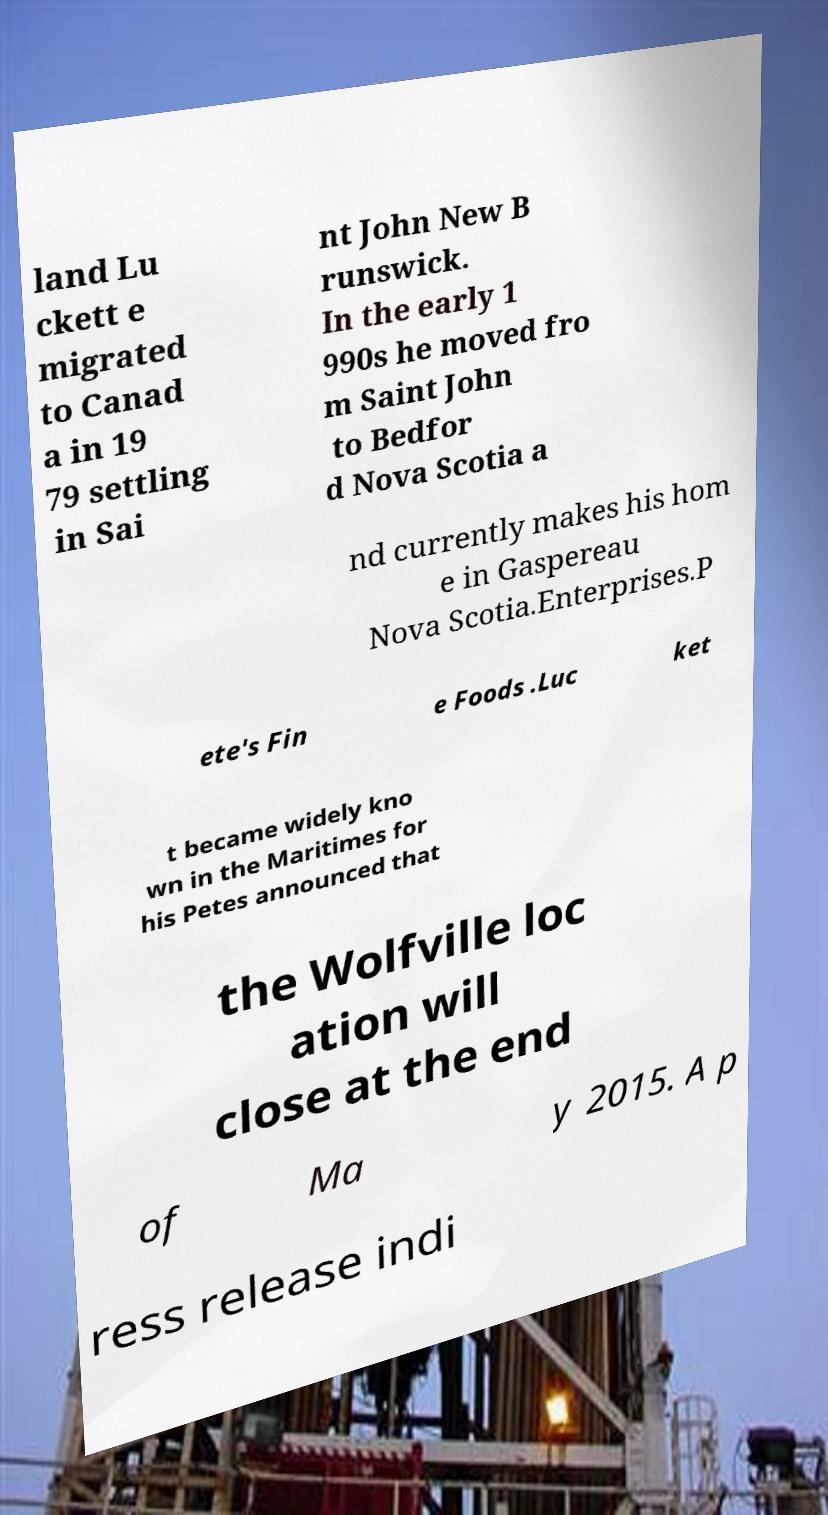What messages or text are displayed in this image? I need them in a readable, typed format. land Lu ckett e migrated to Canad a in 19 79 settling in Sai nt John New B runswick. In the early 1 990s he moved fro m Saint John to Bedfor d Nova Scotia a nd currently makes his hom e in Gaspereau Nova Scotia.Enterprises.P ete's Fin e Foods .Luc ket t became widely kno wn in the Maritimes for his Petes announced that the Wolfville loc ation will close at the end of Ma y 2015. A p ress release indi 